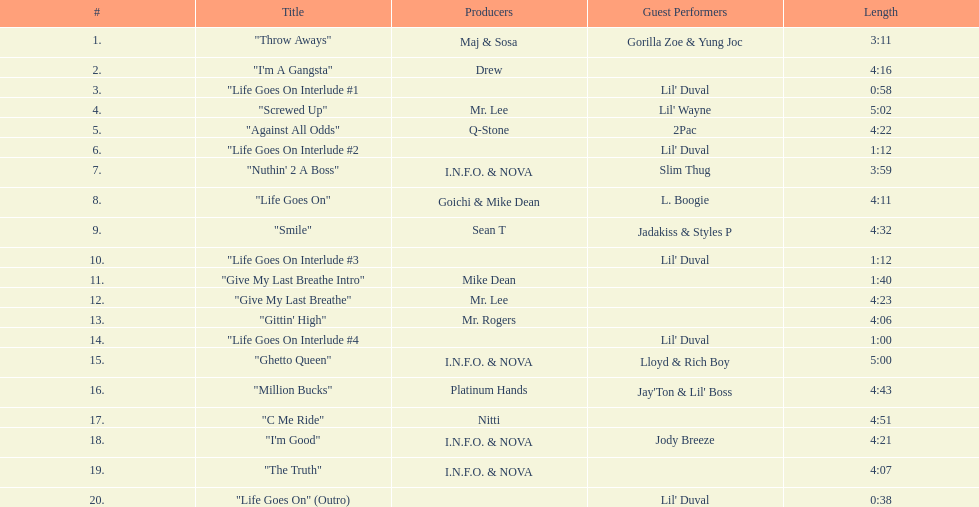How long is track number 11? 1:40. Can you parse all the data within this table? {'header': ['#', 'Title', 'Producers', 'Guest Performers', 'Length'], 'rows': [['1.', '"Throw Aways"', 'Maj & Sosa', 'Gorilla Zoe & Yung Joc', '3:11'], ['2.', '"I\'m A Gangsta"', 'Drew', '', '4:16'], ['3.', '"Life Goes On Interlude #1', '', "Lil' Duval", '0:58'], ['4.', '"Screwed Up"', 'Mr. Lee', "Lil' Wayne", '5:02'], ['5.', '"Against All Odds"', 'Q-Stone', '2Pac', '4:22'], ['6.', '"Life Goes On Interlude #2', '', "Lil' Duval", '1:12'], ['7.', '"Nuthin\' 2 A Boss"', 'I.N.F.O. & NOVA', 'Slim Thug', '3:59'], ['8.', '"Life Goes On"', 'Goichi & Mike Dean', 'L. Boogie', '4:11'], ['9.', '"Smile"', 'Sean T', 'Jadakiss & Styles P', '4:32'], ['10.', '"Life Goes On Interlude #3', '', "Lil' Duval", '1:12'], ['11.', '"Give My Last Breathe Intro"', 'Mike Dean', '', '1:40'], ['12.', '"Give My Last Breathe"', 'Mr. Lee', '', '4:23'], ['13.', '"Gittin\' High"', 'Mr. Rogers', '', '4:06'], ['14.', '"Life Goes On Interlude #4', '', "Lil' Duval", '1:00'], ['15.', '"Ghetto Queen"', 'I.N.F.O. & NOVA', 'Lloyd & Rich Boy', '5:00'], ['16.', '"Million Bucks"', 'Platinum Hands', "Jay'Ton & Lil' Boss", '4:43'], ['17.', '"C Me Ride"', 'Nitti', '', '4:51'], ['18.', '"I\'m Good"', 'I.N.F.O. & NOVA', 'Jody Breeze', '4:21'], ['19.', '"The Truth"', 'I.N.F.O. & NOVA', '', '4:07'], ['20.', '"Life Goes On" (Outro)', '', "Lil' Duval", '0:38']]} 